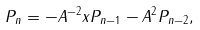Convert formula to latex. <formula><loc_0><loc_0><loc_500><loc_500>P _ { n } = - A ^ { - 2 } x P _ { n - 1 } - A ^ { 2 } P _ { n - 2 } ,</formula> 